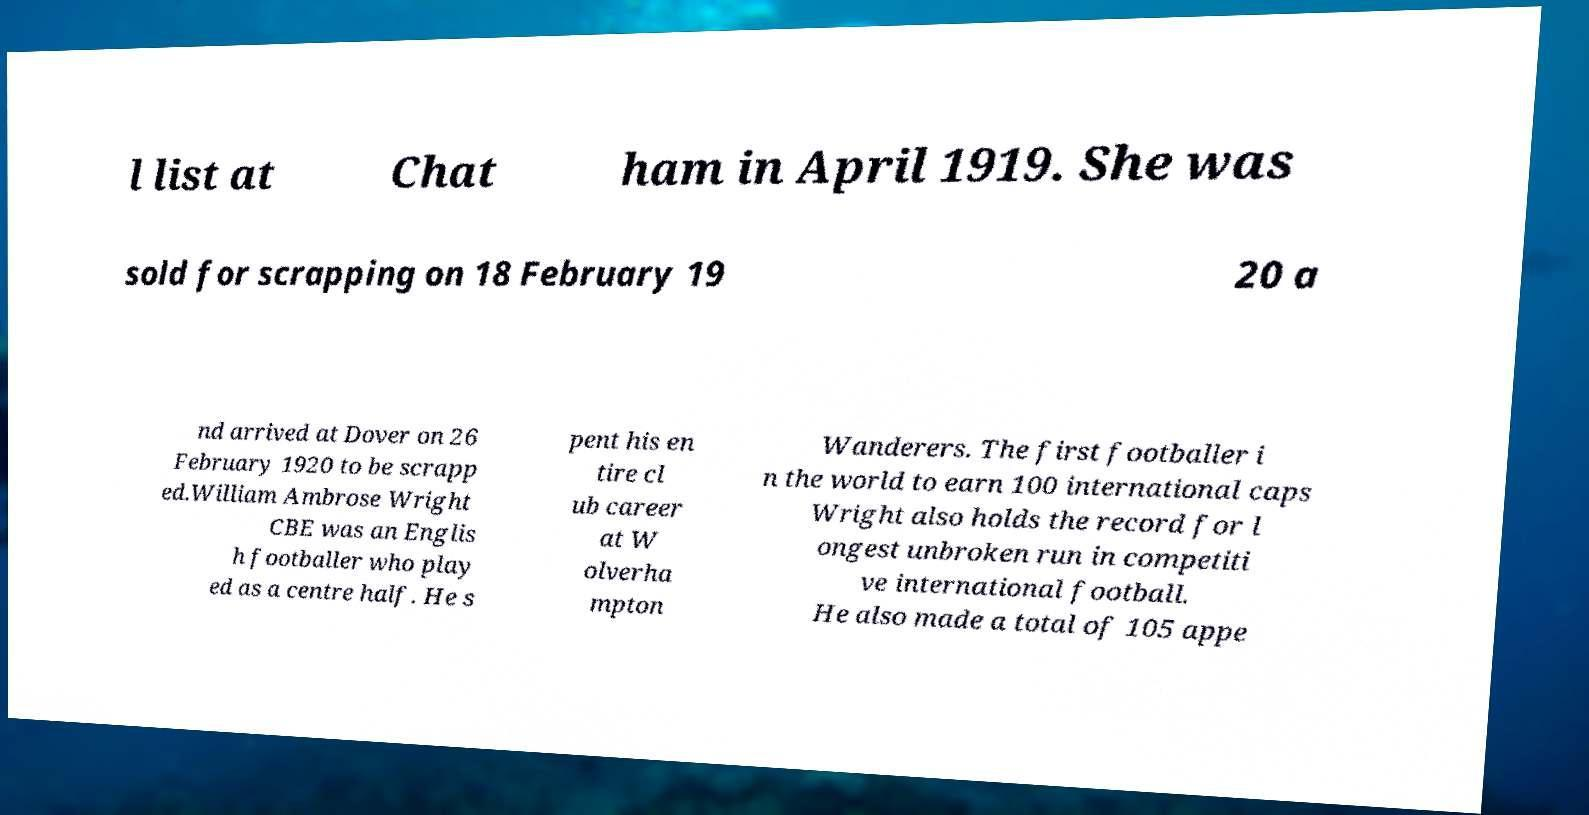For documentation purposes, I need the text within this image transcribed. Could you provide that? l list at Chat ham in April 1919. She was sold for scrapping on 18 February 19 20 a nd arrived at Dover on 26 February 1920 to be scrapp ed.William Ambrose Wright CBE was an Englis h footballer who play ed as a centre half. He s pent his en tire cl ub career at W olverha mpton Wanderers. The first footballer i n the world to earn 100 international caps Wright also holds the record for l ongest unbroken run in competiti ve international football. He also made a total of 105 appe 